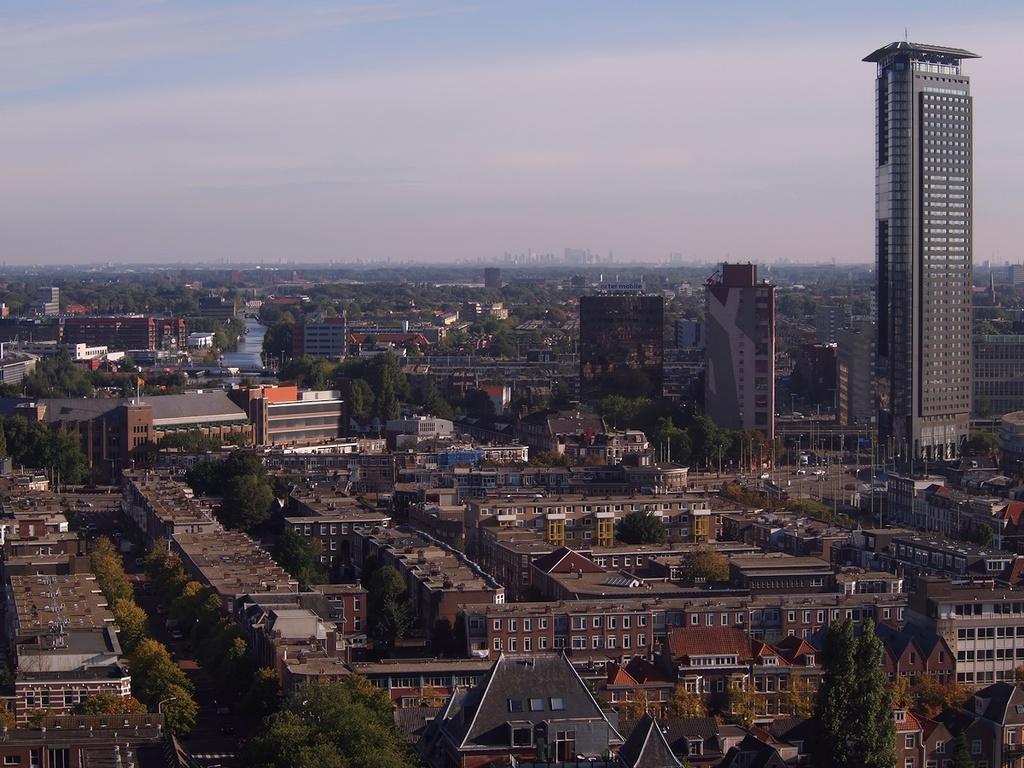Please provide a concise description of this image. In this image we can see the aerial view of the city where there are so many buildings in the middle and there are trees in between them. At the top there is sky. In between the buildings we can see that there are roads on which there are vehicles. 